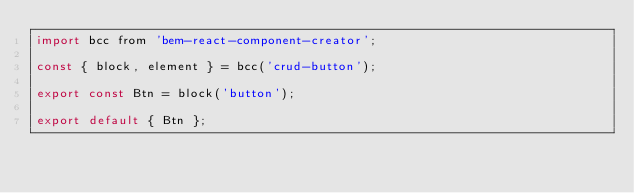Convert code to text. <code><loc_0><loc_0><loc_500><loc_500><_JavaScript_>import bcc from 'bem-react-component-creator';

const { block, element } = bcc('crud-button');

export const Btn = block('button');

export default { Btn };
</code> 